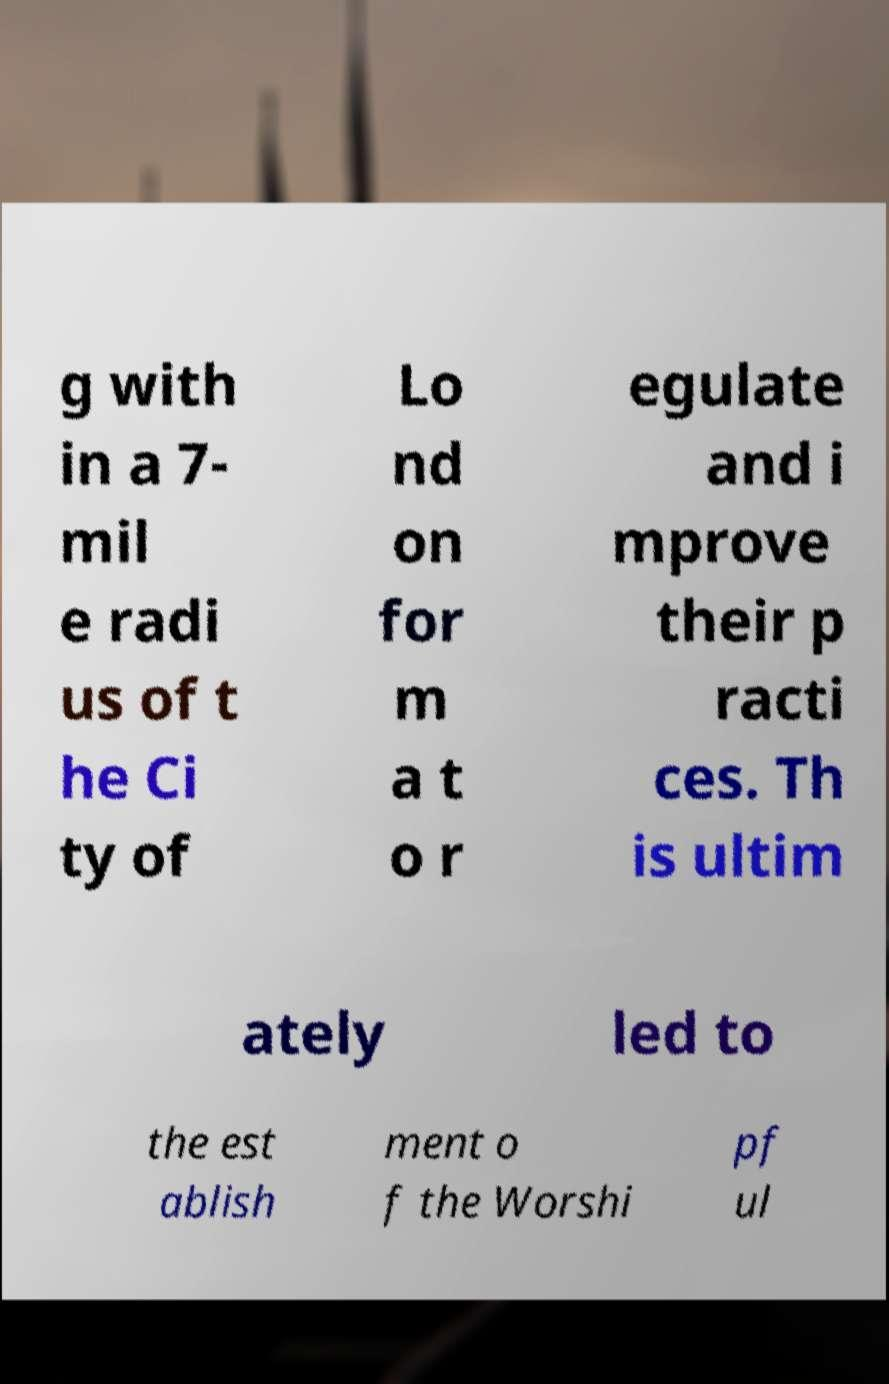Can you read and provide the text displayed in the image?This photo seems to have some interesting text. Can you extract and type it out for me? g with in a 7- mil e radi us of t he Ci ty of Lo nd on for m a t o r egulate and i mprove their p racti ces. Th is ultim ately led to the est ablish ment o f the Worshi pf ul 